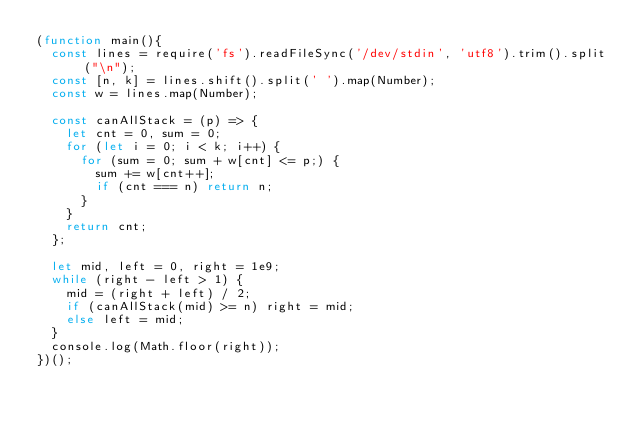Convert code to text. <code><loc_0><loc_0><loc_500><loc_500><_JavaScript_>(function main(){
  const lines = require('fs').readFileSync('/dev/stdin', 'utf8').trim().split("\n");
  const [n, k] = lines.shift().split(' ').map(Number);
  const w = lines.map(Number);

  const canAllStack = (p) => {
    let cnt = 0, sum = 0;
    for (let i = 0; i < k; i++) {
      for (sum = 0; sum + w[cnt] <= p;) {
        sum += w[cnt++];
        if (cnt === n) return n;
      }
    }
    return cnt;
  };

  let mid, left = 0, right = 1e9;
  while (right - left > 1) {
    mid = (right + left) / 2;
    if (canAllStack(mid) >= n) right = mid;
    else left = mid;
  }
  console.log(Math.floor(right));
})();

</code> 